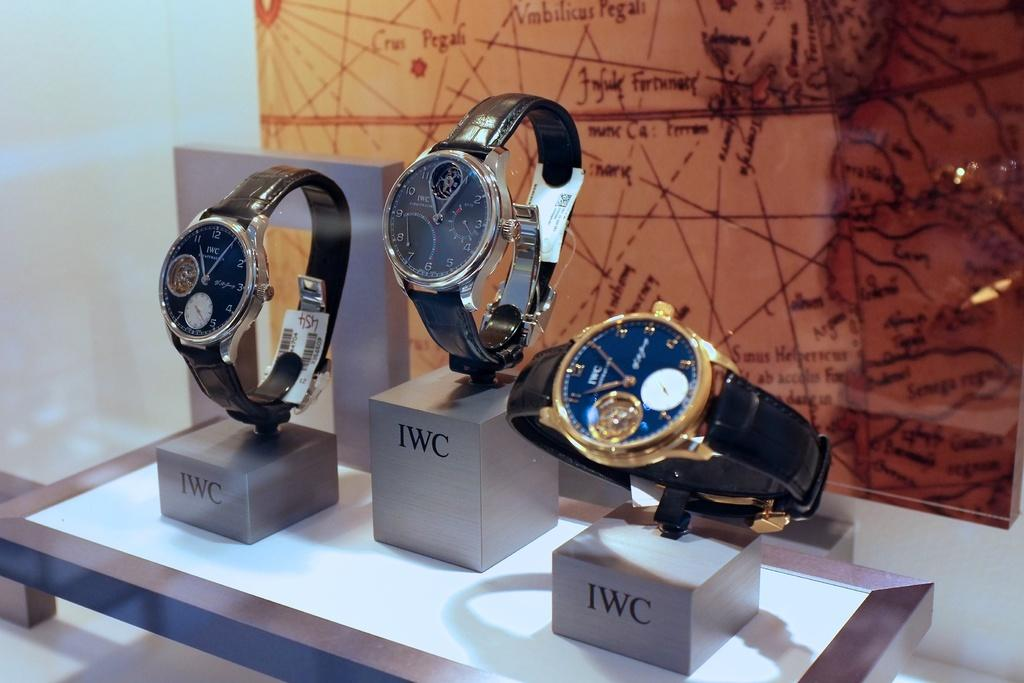<image>
Provide a brief description of the given image. Wrist watches on top of mini boxes that say IWC. 